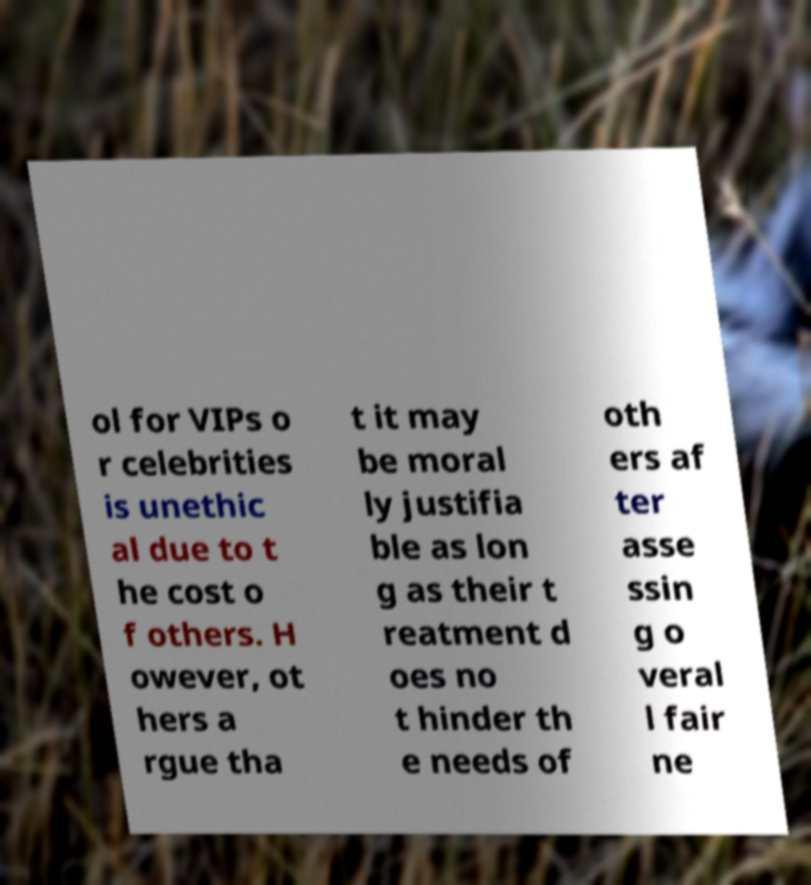Can you accurately transcribe the text from the provided image for me? ol for VIPs o r celebrities is unethic al due to t he cost o f others. H owever, ot hers a rgue tha t it may be moral ly justifia ble as lon g as their t reatment d oes no t hinder th e needs of oth ers af ter asse ssin g o veral l fair ne 